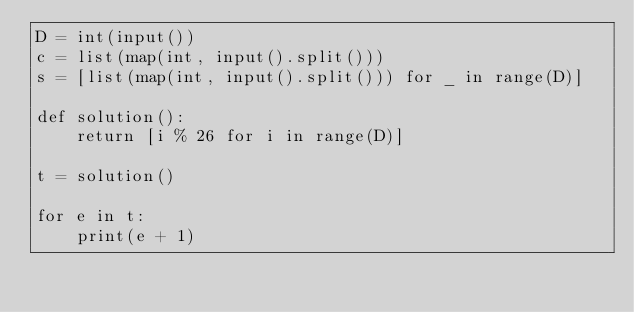Convert code to text. <code><loc_0><loc_0><loc_500><loc_500><_Python_>D = int(input())
c = list(map(int, input().split()))
s = [list(map(int, input().split())) for _ in range(D)]

def solution():
    return [i % 26 for i in range(D)]

t = solution()

for e in t:
    print(e + 1)
</code> 